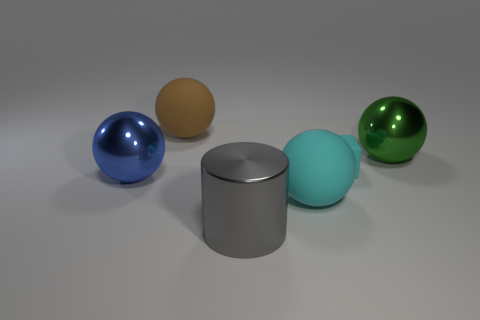Is there a big matte object of the same color as the block?
Give a very brief answer. Yes. The small cyan thing behind the big metallic cylinder has what shape?
Your answer should be compact. Cube. The tiny matte thing has what color?
Offer a very short reply. Cyan. The large thing that is made of the same material as the big cyan sphere is what color?
Provide a short and direct response. Brown. How many big brown objects have the same material as the cube?
Your answer should be very brief. 1. How many green things are in front of the large cyan matte thing?
Your response must be concise. 0. Does the object left of the large brown thing have the same material as the cylinder to the left of the big green ball?
Make the answer very short. Yes. Are there more big brown balls that are behind the large green shiny thing than small matte objects that are behind the brown object?
Your response must be concise. Yes. There is a ball that is the same color as the tiny rubber object; what material is it?
Keep it short and to the point. Rubber. Are there any other things that are the same shape as the blue object?
Your answer should be compact. Yes. 